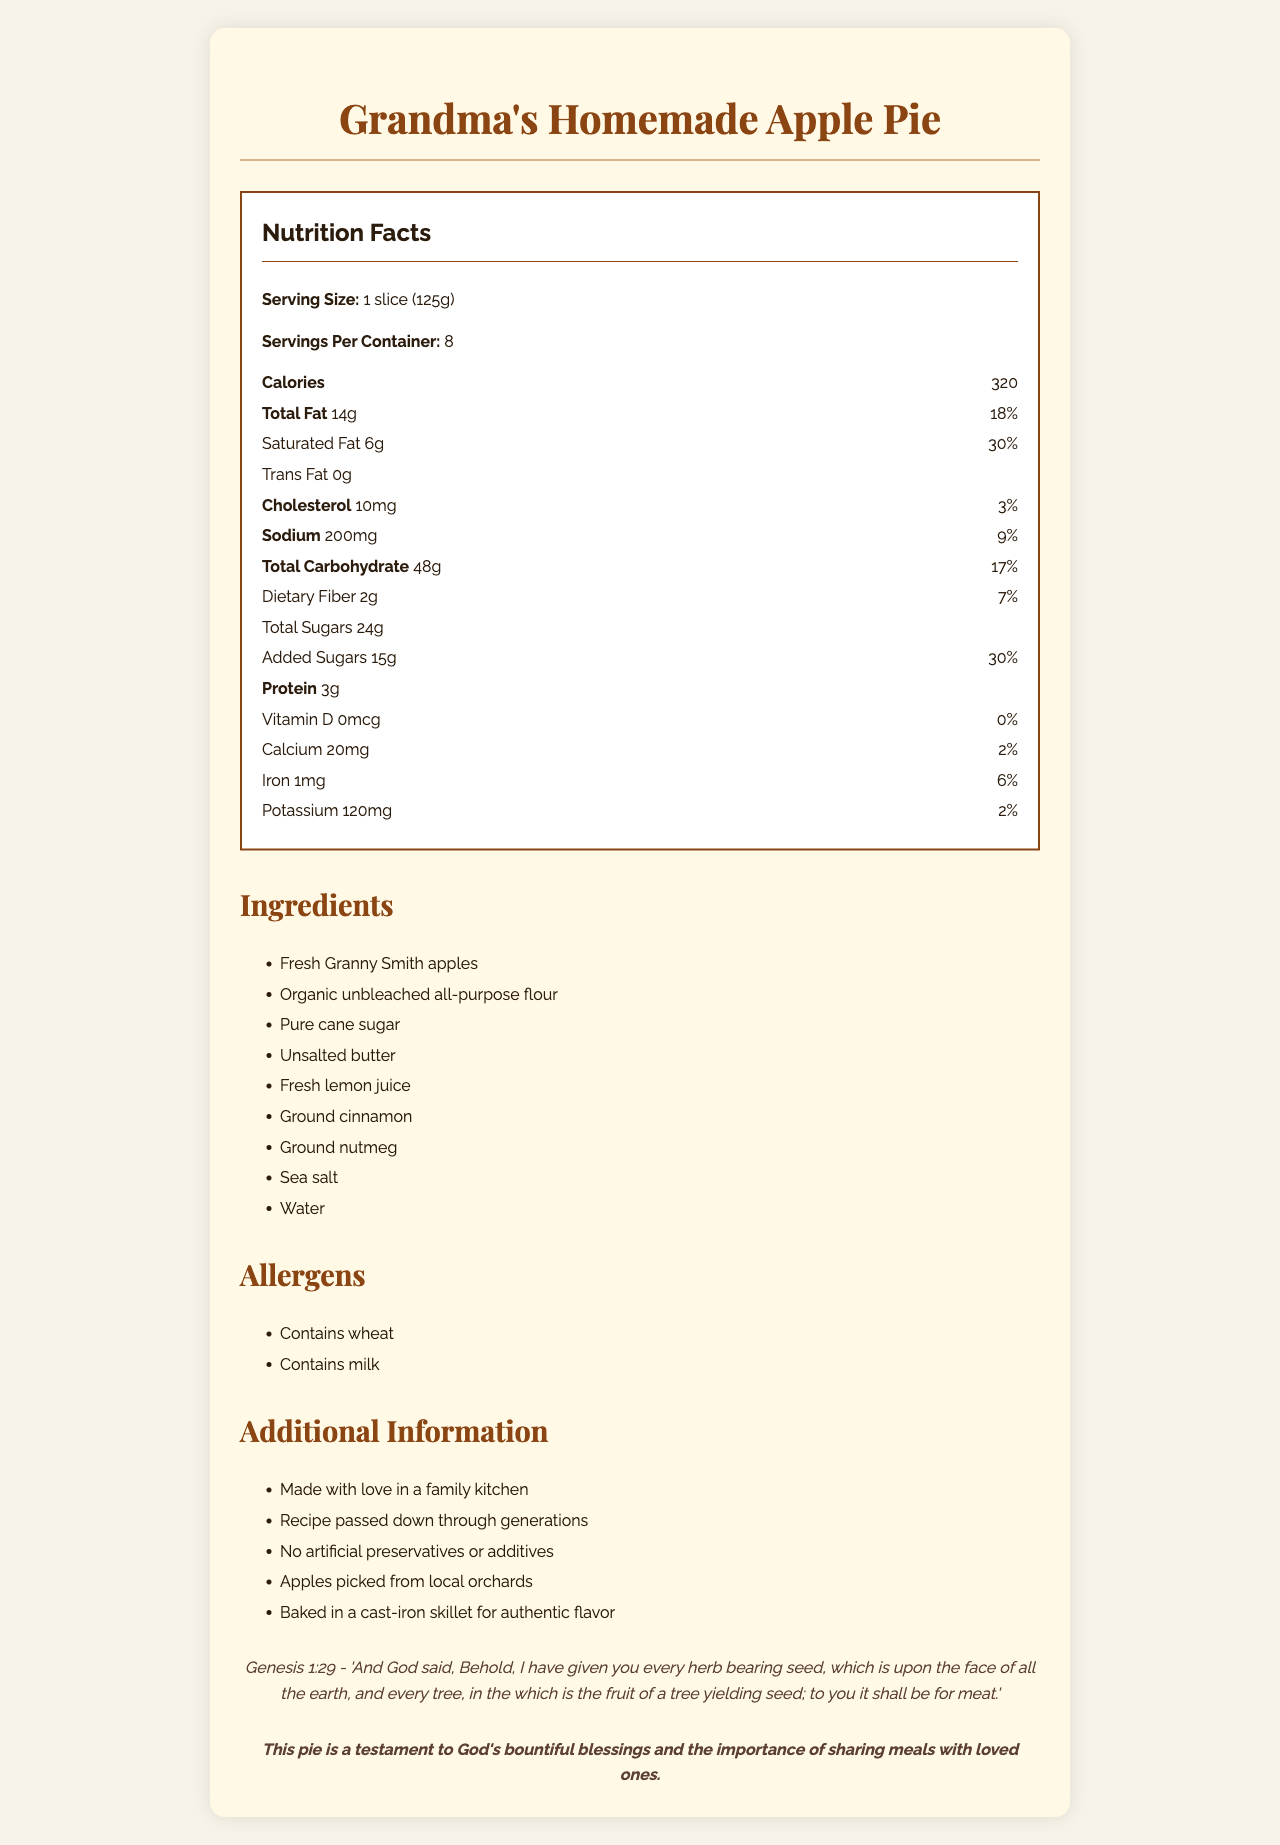what is the serving size? The serving size is explicitly mentioned at the beginning of the Nutrition Facts section in the document.
Answer: 1 slice (125g) how many calories are there per serving? The calories per serving are listed right under the serving size in the Nutrition Facts section.
Answer: 320 how much total fat is in one serving, both in grams and daily value percentage? The total fat content is stated as 14g, which is 18% of the daily value.
Answer: 14g, 18% what kind of apples are used in the pie? The type of apples used is listed in the ingredients section.
Answer: Fresh Granny Smith apples what are the allergens mentioned in the document? The allergens listed are wheat and milk, as noted in the allergens section.
Answer: Contains wheat and milk how much saturated fat is in one serving? A. 2g B. 4g C. 6g D. 8g The saturated fat content per serving is clearly stated as 6g in the Nutrition Facts section.
Answer: C. 6g what is the daily value percentage of iron in one serving? I. 2% II. 4% III. 6% IV. 8% The daily value percentage for iron is listed as 6% in the Nutrition Facts section.
Answer: III. 6% are there any artificial preservatives in the apple pie? The Additional Information section explicitly states that there are "No artificial preservatives or additives."
Answer: No is this pie gluten-free? The document lists wheat as an allergen, indicating that the pie is not gluten-free.
Answer: No what is the biblical reference mentioned in the document? The biblical reference is clearly quoted in the document.
Answer: Genesis 1:29 - "And God said, Behold, I have given you every herb bearing seed, which is upon the face of all the earth, and every tree, in the which is the fruit of a tree yielding seed; to you it shall be for meat." describe the main idea of the document. The document details the nutritional content and ingredients of the apple pie, stresses natural and local components, links the recipe to family traditions and Christian faith, and includes a specific biblical reference.
Answer: The document provides nutritional information, ingredients list, allergen warnings, and additional notes about Grandma's Homemade Apple Pie. It emphasizes the use of natural, local ingredients and traditional cooking methods, making it a wholesome family recipe passed down through generations. The document also highlights the religious and family values connected to the pie. does the document provide the specific amount of each ingredient used in the pie? The document lists the ingredients but does not provide the specific quantities for each used in the recipe.
Answer: Cannot be determined 